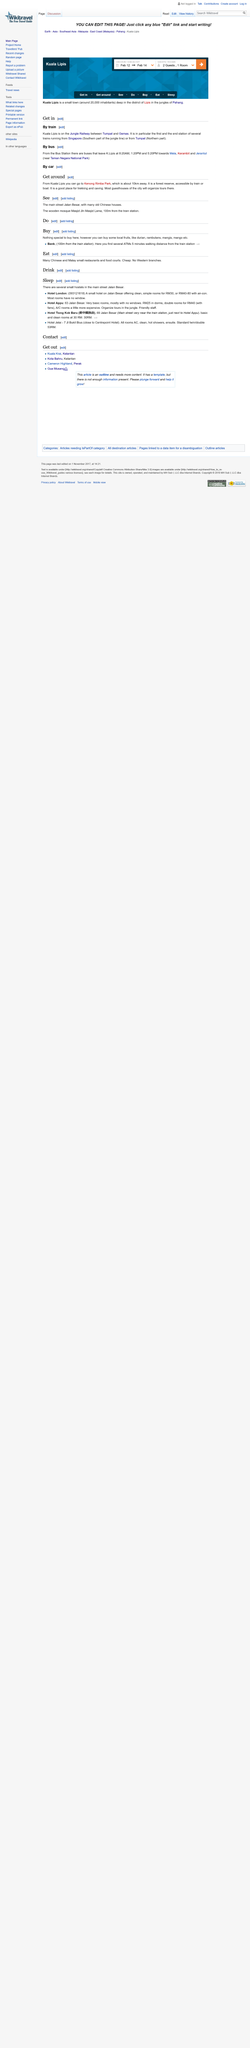Give some essential details in this illustration. Buses depart from K. Lipis at 8:20 AM, 1:20 PM, and 5:20 PM. Kenong Rimba Park is located 10 kilometers away from Kuala Lipis, a town in Pahang, Malaysia. In the following passage, four methods of transportation are listed: train, bus, car, and boat. 